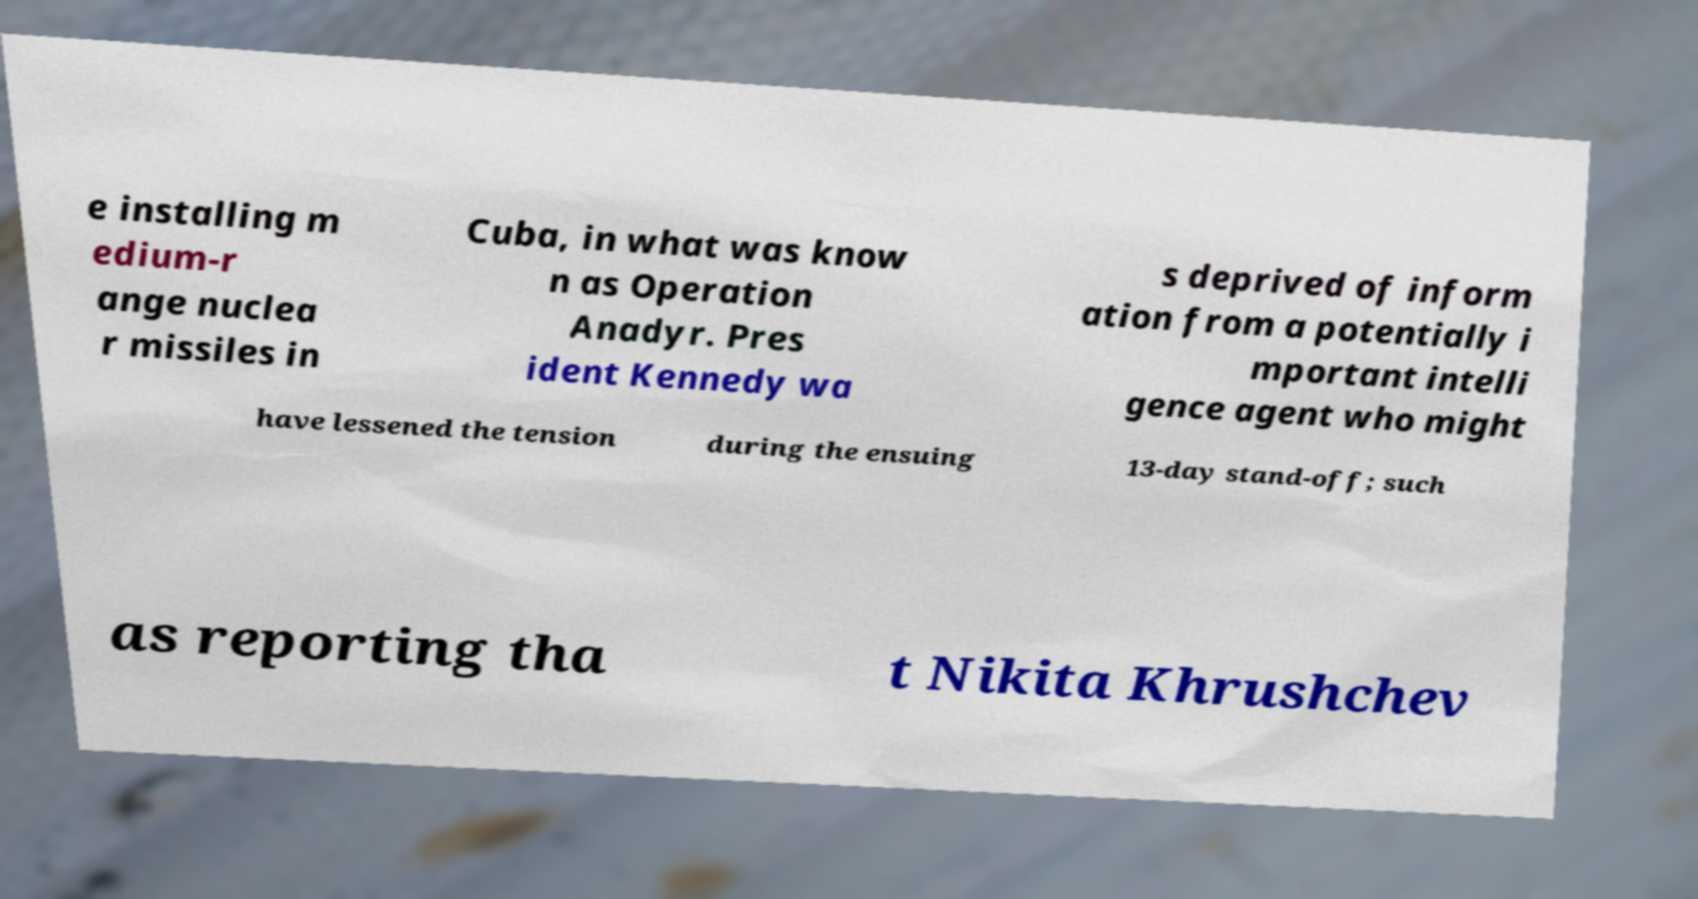Could you assist in decoding the text presented in this image and type it out clearly? e installing m edium-r ange nuclea r missiles in Cuba, in what was know n as Operation Anadyr. Pres ident Kennedy wa s deprived of inform ation from a potentially i mportant intelli gence agent who might have lessened the tension during the ensuing 13-day stand-off; such as reporting tha t Nikita Khrushchev 